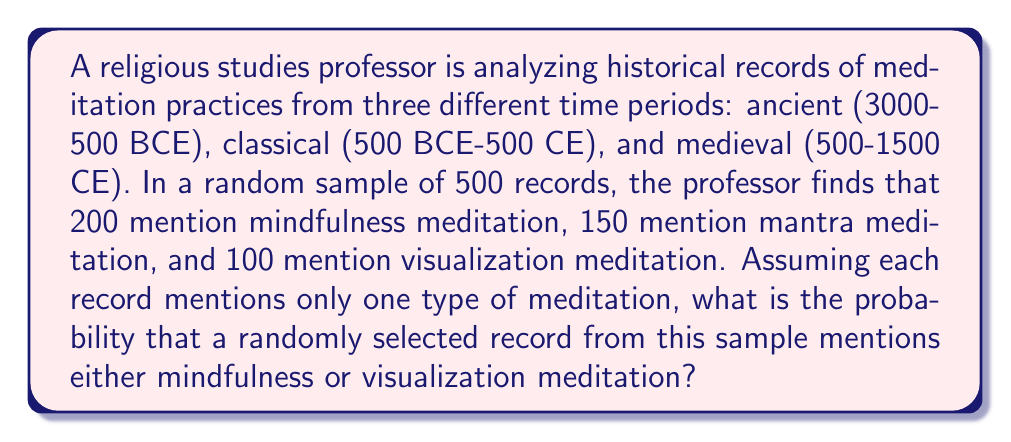Can you answer this question? To solve this problem, we need to use the concept of probability and the addition rule for mutually exclusive events.

Given:
- Total number of records in the sample: 500
- Records mentioning mindfulness meditation: 200
- Records mentioning mantra meditation: 150
- Records mentioning visualization meditation: 100

Step 1: Calculate the probability of selecting a record mentioning mindfulness meditation.
$P(\text{Mindfulness}) = \frac{200}{500} = 0.4$

Step 2: Calculate the probability of selecting a record mentioning visualization meditation.
$P(\text{Visualization}) = \frac{100}{500} = 0.2$

Step 3: Since we want the probability of selecting a record mentioning either mindfulness or visualization meditation, and these events are mutually exclusive (each record mentions only one type of meditation), we can use the addition rule:

$P(\text{Mindfulness or Visualization}) = P(\text{Mindfulness}) + P(\text{Visualization})$

$P(\text{Mindfulness or Visualization}) = 0.4 + 0.2 = 0.6$

Therefore, the probability of randomly selecting a record that mentions either mindfulness or visualization meditation is 0.6 or 60%.
Answer: 0.6 or 60% 